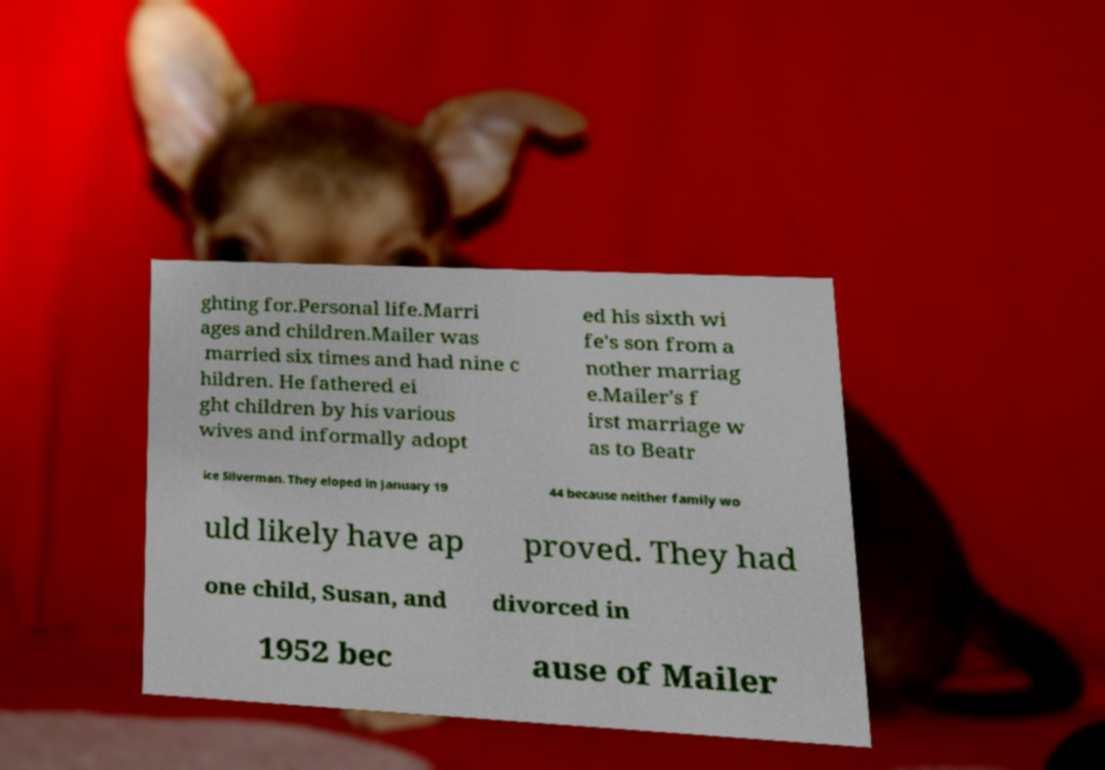Could you assist in decoding the text presented in this image and type it out clearly? ghting for.Personal life.Marri ages and children.Mailer was married six times and had nine c hildren. He fathered ei ght children by his various wives and informally adopt ed his sixth wi fe's son from a nother marriag e.Mailer's f irst marriage w as to Beatr ice Silverman. They eloped in January 19 44 because neither family wo uld likely have ap proved. They had one child, Susan, and divorced in 1952 bec ause of Mailer 